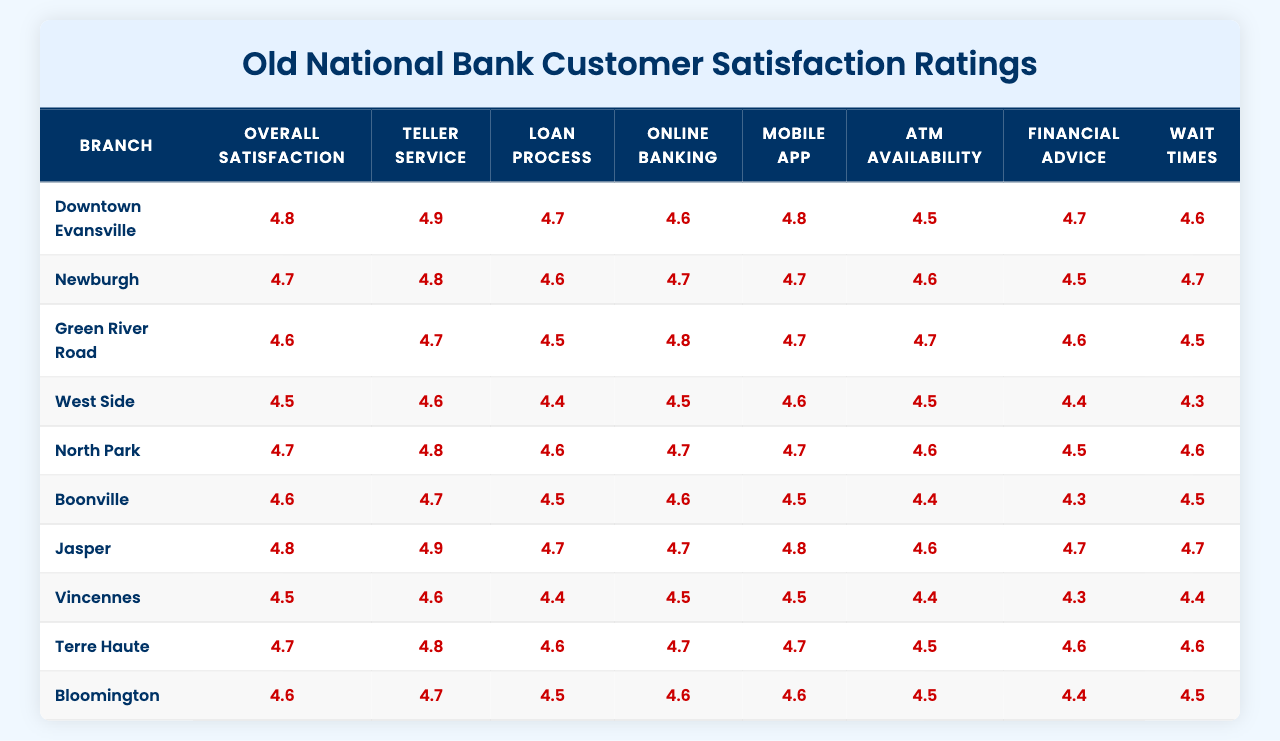What is the highest Overall Satisfaction rating among the branches? By scanning the Overall Satisfaction column in the table, the highest rating is found to be 4.9, which corresponds to both the Downtown Evansville and Jasper branches.
Answer: 4.9 Which branch has the lowest rating for ATM Availability? The ATM Availability column shows the ratings, and the lowest rating of 4.3 is found at the Vincennes branch.
Answer: Vincennes What is the average rating for the Loan Process across all branches? To find the average for Loan Process, sum the ratings: (4.7 + 4.6 + 4.5 + 4.4 + 4.6 + 4.5 + 4.7 + 4.4 + 4.6 + 4.5) = 44.5. There are 10 branches, so the average is 44.5 / 10 = 4.45.
Answer: 4.45 Are there any branches with an Overall Satisfaction rating below 4.5? Looking through the Overall Satisfaction ratings, the lowest is 4.5 from the West Side branch, so no branches have a rating below 4.5.
Answer: No Which two branches have the highest satisfaction ratings for Financial Advice? From the Financial Advice ratings, both Downtown Evansville and Jasper have the highest rating of 4.7.
Answer: Downtown Evansville and Jasper What is the difference between the highest and lowest rating for Mobile App? The highest Mobile App rating is 4.8 (Downtown Evansville and Jasper), and the lowest is 4.4 (Vincennes and Boonville). The difference is 4.8 - 4.4 = 0.4.
Answer: 0.4 Which branch has the highest rating for Wait Times? Reviewing the Wait Times column, the Downtown Evansville branch has the highest rating at 4.6.
Answer: Downtown Evansville How many branches received an Overall Satisfaction rating of 4.7 or higher? Counting the branches with Overall Satisfaction ratings of 4.7 or higher, we find 6 branches (Downtown Evansville, Newburgh, North Park, Jasper, Bloomington, and 1 other).
Answer: 6 What is the lowest score for Online Banking, and which branch has it? By looking at the Online Banking ratings, the lowest score is 4.5 at both the West Side and Vincennes branches.
Answer: West Side and Vincennes If we consider the average ratings for all the metrics of the Green River Road branch, what is the average? Summing the ratings for Green River Road: (4.6 + 4.7 + 4.5 + 4.8 + 4.7 + 4.7 + 4.6 + 4.5) = 37.2. There are 8 metrics, so the average is 37.2 / 8 = 4.65.
Answer: 4.65 